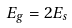Convert formula to latex. <formula><loc_0><loc_0><loc_500><loc_500>E _ { g } = 2 E _ { s }</formula> 